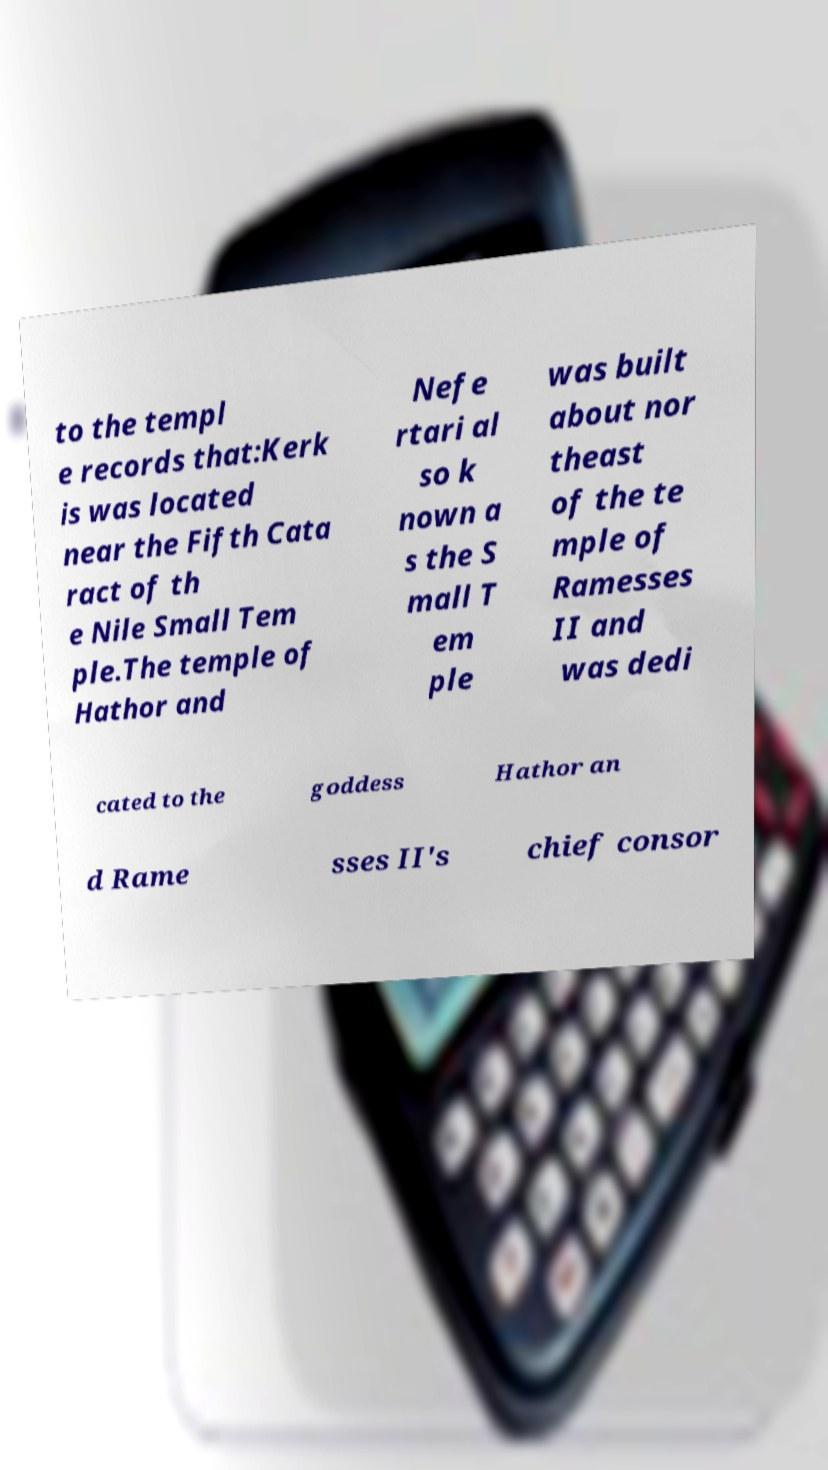There's text embedded in this image that I need extracted. Can you transcribe it verbatim? to the templ e records that:Kerk is was located near the Fifth Cata ract of th e Nile Small Tem ple.The temple of Hathor and Nefe rtari al so k nown a s the S mall T em ple was built about nor theast of the te mple of Ramesses II and was dedi cated to the goddess Hathor an d Rame sses II's chief consor 